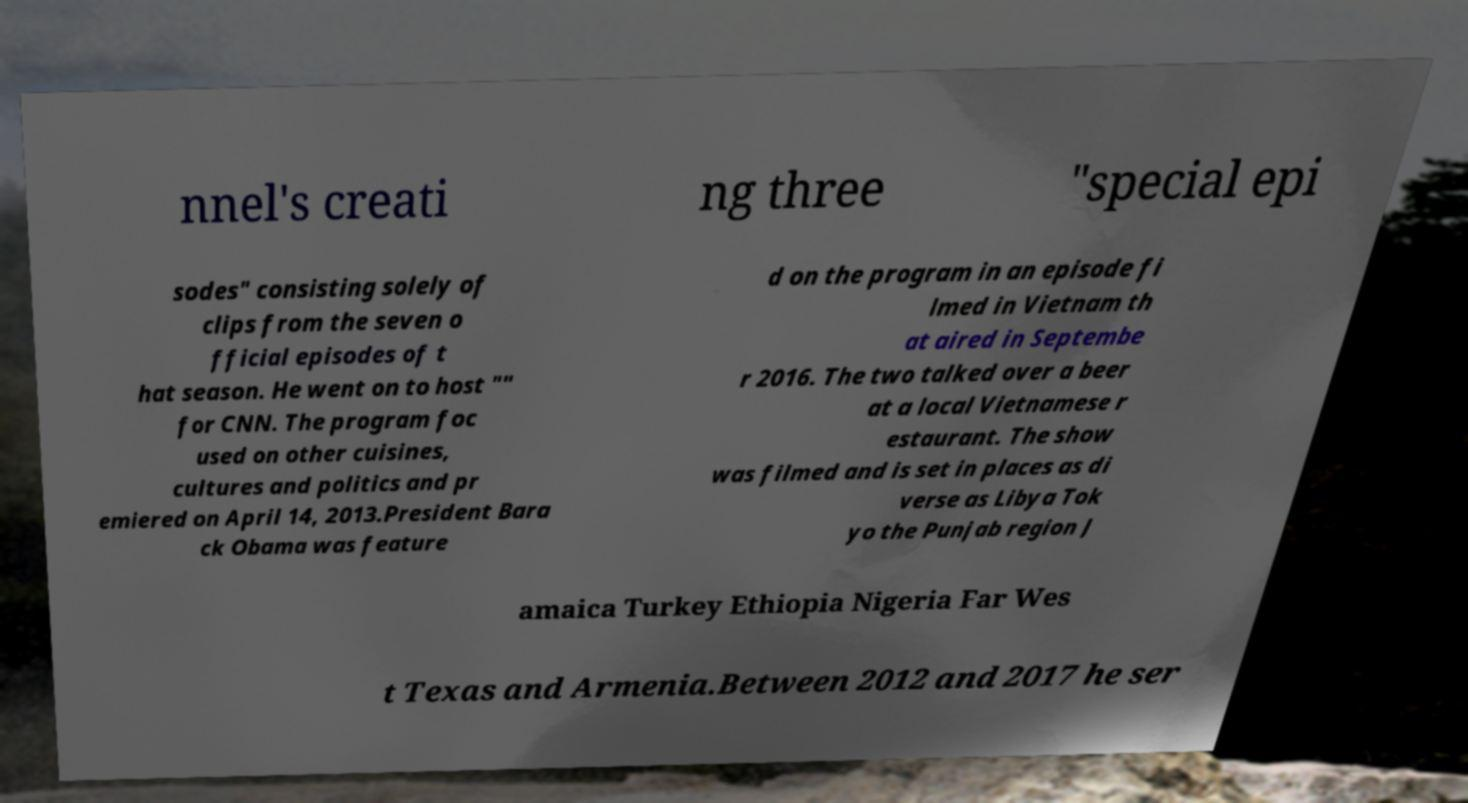There's text embedded in this image that I need extracted. Can you transcribe it verbatim? nnel's creati ng three "special epi sodes" consisting solely of clips from the seven o fficial episodes of t hat season. He went on to host "" for CNN. The program foc used on other cuisines, cultures and politics and pr emiered on April 14, 2013.President Bara ck Obama was feature d on the program in an episode fi lmed in Vietnam th at aired in Septembe r 2016. The two talked over a beer at a local Vietnamese r estaurant. The show was filmed and is set in places as di verse as Libya Tok yo the Punjab region J amaica Turkey Ethiopia Nigeria Far Wes t Texas and Armenia.Between 2012 and 2017 he ser 